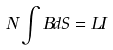<formula> <loc_0><loc_0><loc_500><loc_500>N \int B d S = L I</formula> 